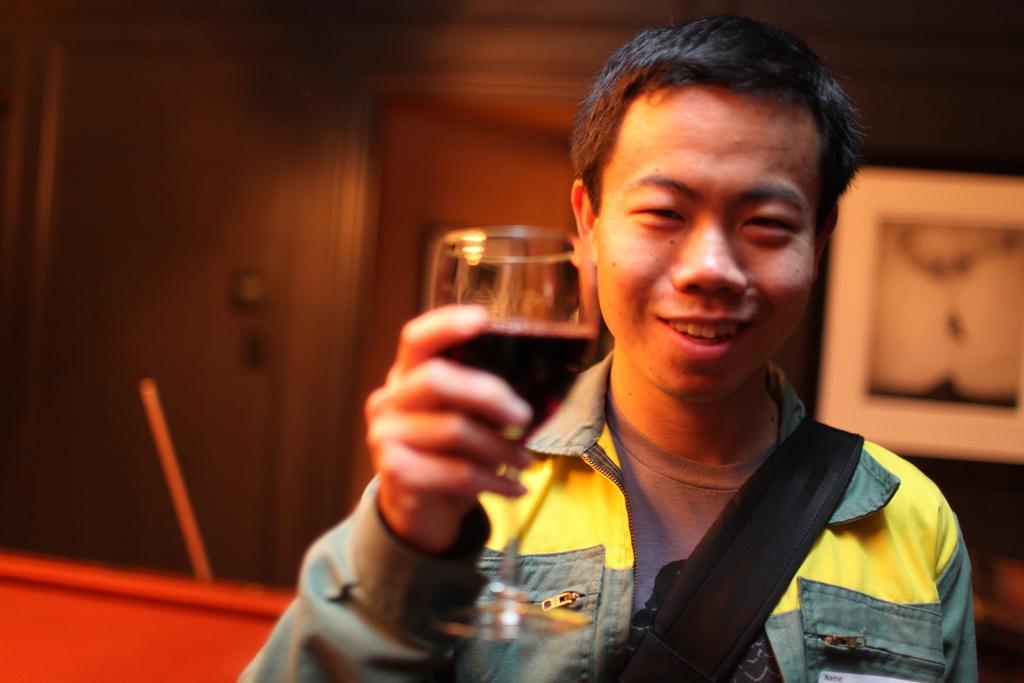Could you give a brief overview of what you see in this image? A person holding a wine glass catching in his hand, he is wearing a yellow jacket and he is smiling. and the back side there is a wall and a painting. 